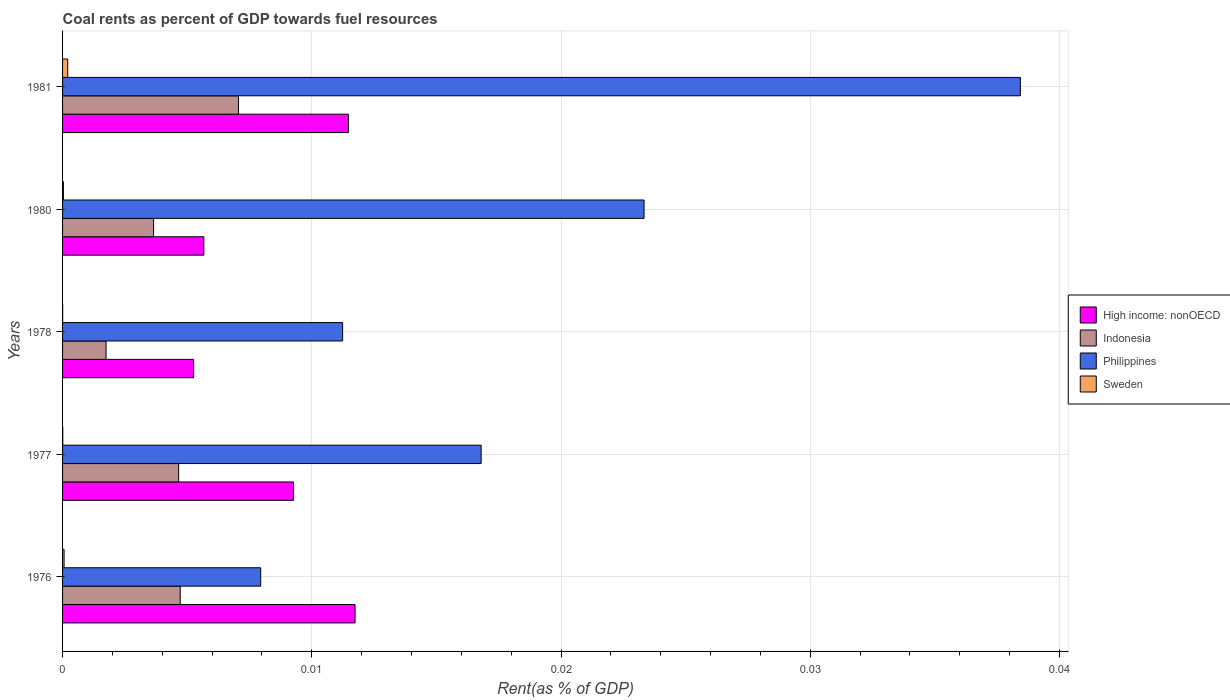How many bars are there on the 3rd tick from the bottom?
Give a very brief answer. 4. What is the coal rent in Indonesia in 1977?
Provide a succinct answer. 0. Across all years, what is the maximum coal rent in Sweden?
Make the answer very short. 0. Across all years, what is the minimum coal rent in High income: nonOECD?
Make the answer very short. 0.01. In which year was the coal rent in High income: nonOECD maximum?
Your answer should be very brief. 1976. In which year was the coal rent in Philippines minimum?
Your answer should be very brief. 1976. What is the total coal rent in High income: nonOECD in the graph?
Your answer should be very brief. 0.04. What is the difference between the coal rent in Indonesia in 1978 and that in 1980?
Provide a succinct answer. -0. What is the difference between the coal rent in High income: nonOECD in 1980 and the coal rent in Indonesia in 1977?
Your answer should be very brief. 0. What is the average coal rent in Indonesia per year?
Ensure brevity in your answer.  0. In the year 1981, what is the difference between the coal rent in High income: nonOECD and coal rent in Indonesia?
Keep it short and to the point. 0. What is the ratio of the coal rent in Indonesia in 1978 to that in 1981?
Offer a terse response. 0.25. What is the difference between the highest and the second highest coal rent in Philippines?
Offer a very short reply. 0.02. What is the difference between the highest and the lowest coal rent in Sweden?
Make the answer very short. 0. Is it the case that in every year, the sum of the coal rent in Sweden and coal rent in Philippines is greater than the sum of coal rent in Indonesia and coal rent in High income: nonOECD?
Ensure brevity in your answer.  No. What does the 2nd bar from the top in 1978 represents?
Give a very brief answer. Philippines. What does the 1st bar from the bottom in 1977 represents?
Give a very brief answer. High income: nonOECD. Is it the case that in every year, the sum of the coal rent in Sweden and coal rent in Indonesia is greater than the coal rent in High income: nonOECD?
Offer a very short reply. No. How many years are there in the graph?
Offer a terse response. 5. What is the difference between two consecutive major ticks on the X-axis?
Give a very brief answer. 0.01. Does the graph contain any zero values?
Provide a short and direct response. No. Does the graph contain grids?
Your response must be concise. Yes. How many legend labels are there?
Your answer should be very brief. 4. What is the title of the graph?
Your response must be concise. Coal rents as percent of GDP towards fuel resources. Does "Zambia" appear as one of the legend labels in the graph?
Your answer should be very brief. No. What is the label or title of the X-axis?
Give a very brief answer. Rent(as % of GDP). What is the label or title of the Y-axis?
Your answer should be compact. Years. What is the Rent(as % of GDP) in High income: nonOECD in 1976?
Provide a short and direct response. 0.01. What is the Rent(as % of GDP) in Indonesia in 1976?
Provide a succinct answer. 0. What is the Rent(as % of GDP) of Philippines in 1976?
Offer a terse response. 0.01. What is the Rent(as % of GDP) in Sweden in 1976?
Provide a succinct answer. 6.06616895971239e-5. What is the Rent(as % of GDP) in High income: nonOECD in 1977?
Offer a very short reply. 0.01. What is the Rent(as % of GDP) in Indonesia in 1977?
Offer a very short reply. 0. What is the Rent(as % of GDP) in Philippines in 1977?
Ensure brevity in your answer.  0.02. What is the Rent(as % of GDP) in Sweden in 1977?
Give a very brief answer. 8.869305403427698e-6. What is the Rent(as % of GDP) in High income: nonOECD in 1978?
Offer a very short reply. 0.01. What is the Rent(as % of GDP) in Indonesia in 1978?
Your response must be concise. 0. What is the Rent(as % of GDP) of Philippines in 1978?
Offer a very short reply. 0.01. What is the Rent(as % of GDP) in Sweden in 1978?
Offer a terse response. 4.018528953786889e-6. What is the Rent(as % of GDP) in High income: nonOECD in 1980?
Your answer should be compact. 0.01. What is the Rent(as % of GDP) of Indonesia in 1980?
Provide a succinct answer. 0. What is the Rent(as % of GDP) of Philippines in 1980?
Your answer should be compact. 0.02. What is the Rent(as % of GDP) in Sweden in 1980?
Keep it short and to the point. 3.34719228458372e-5. What is the Rent(as % of GDP) in High income: nonOECD in 1981?
Your response must be concise. 0.01. What is the Rent(as % of GDP) in Indonesia in 1981?
Your answer should be compact. 0.01. What is the Rent(as % of GDP) in Philippines in 1981?
Offer a terse response. 0.04. What is the Rent(as % of GDP) of Sweden in 1981?
Provide a short and direct response. 0. Across all years, what is the maximum Rent(as % of GDP) of High income: nonOECD?
Your answer should be compact. 0.01. Across all years, what is the maximum Rent(as % of GDP) in Indonesia?
Give a very brief answer. 0.01. Across all years, what is the maximum Rent(as % of GDP) in Philippines?
Keep it short and to the point. 0.04. Across all years, what is the maximum Rent(as % of GDP) in Sweden?
Offer a terse response. 0. Across all years, what is the minimum Rent(as % of GDP) in High income: nonOECD?
Give a very brief answer. 0.01. Across all years, what is the minimum Rent(as % of GDP) in Indonesia?
Give a very brief answer. 0. Across all years, what is the minimum Rent(as % of GDP) in Philippines?
Your answer should be compact. 0.01. Across all years, what is the minimum Rent(as % of GDP) in Sweden?
Ensure brevity in your answer.  4.018528953786889e-6. What is the total Rent(as % of GDP) of High income: nonOECD in the graph?
Provide a short and direct response. 0.04. What is the total Rent(as % of GDP) in Indonesia in the graph?
Your answer should be compact. 0.02. What is the total Rent(as % of GDP) in Philippines in the graph?
Ensure brevity in your answer.  0.1. What is the total Rent(as % of GDP) in Sweden in the graph?
Offer a very short reply. 0. What is the difference between the Rent(as % of GDP) in High income: nonOECD in 1976 and that in 1977?
Keep it short and to the point. 0. What is the difference between the Rent(as % of GDP) of Indonesia in 1976 and that in 1977?
Provide a short and direct response. 0. What is the difference between the Rent(as % of GDP) of Philippines in 1976 and that in 1977?
Keep it short and to the point. -0.01. What is the difference between the Rent(as % of GDP) in High income: nonOECD in 1976 and that in 1978?
Your answer should be very brief. 0.01. What is the difference between the Rent(as % of GDP) in Indonesia in 1976 and that in 1978?
Offer a terse response. 0. What is the difference between the Rent(as % of GDP) of Philippines in 1976 and that in 1978?
Ensure brevity in your answer.  -0. What is the difference between the Rent(as % of GDP) in High income: nonOECD in 1976 and that in 1980?
Provide a short and direct response. 0.01. What is the difference between the Rent(as % of GDP) of Indonesia in 1976 and that in 1980?
Make the answer very short. 0. What is the difference between the Rent(as % of GDP) in Philippines in 1976 and that in 1980?
Offer a terse response. -0.02. What is the difference between the Rent(as % of GDP) of Sweden in 1976 and that in 1980?
Offer a very short reply. 0. What is the difference between the Rent(as % of GDP) of High income: nonOECD in 1976 and that in 1981?
Make the answer very short. 0. What is the difference between the Rent(as % of GDP) in Indonesia in 1976 and that in 1981?
Keep it short and to the point. -0. What is the difference between the Rent(as % of GDP) in Philippines in 1976 and that in 1981?
Your answer should be very brief. -0.03. What is the difference between the Rent(as % of GDP) in Sweden in 1976 and that in 1981?
Offer a terse response. -0. What is the difference between the Rent(as % of GDP) of High income: nonOECD in 1977 and that in 1978?
Keep it short and to the point. 0. What is the difference between the Rent(as % of GDP) in Indonesia in 1977 and that in 1978?
Your answer should be compact. 0. What is the difference between the Rent(as % of GDP) of Philippines in 1977 and that in 1978?
Your answer should be compact. 0.01. What is the difference between the Rent(as % of GDP) in High income: nonOECD in 1977 and that in 1980?
Your answer should be compact. 0. What is the difference between the Rent(as % of GDP) of Indonesia in 1977 and that in 1980?
Your response must be concise. 0. What is the difference between the Rent(as % of GDP) in Philippines in 1977 and that in 1980?
Give a very brief answer. -0.01. What is the difference between the Rent(as % of GDP) in Sweden in 1977 and that in 1980?
Your response must be concise. -0. What is the difference between the Rent(as % of GDP) of High income: nonOECD in 1977 and that in 1981?
Your response must be concise. -0. What is the difference between the Rent(as % of GDP) in Indonesia in 1977 and that in 1981?
Your answer should be very brief. -0. What is the difference between the Rent(as % of GDP) in Philippines in 1977 and that in 1981?
Offer a very short reply. -0.02. What is the difference between the Rent(as % of GDP) of Sweden in 1977 and that in 1981?
Make the answer very short. -0. What is the difference between the Rent(as % of GDP) in High income: nonOECD in 1978 and that in 1980?
Make the answer very short. -0. What is the difference between the Rent(as % of GDP) of Indonesia in 1978 and that in 1980?
Provide a short and direct response. -0. What is the difference between the Rent(as % of GDP) in Philippines in 1978 and that in 1980?
Your response must be concise. -0.01. What is the difference between the Rent(as % of GDP) of High income: nonOECD in 1978 and that in 1981?
Your answer should be very brief. -0.01. What is the difference between the Rent(as % of GDP) of Indonesia in 1978 and that in 1981?
Your answer should be compact. -0.01. What is the difference between the Rent(as % of GDP) of Philippines in 1978 and that in 1981?
Your answer should be very brief. -0.03. What is the difference between the Rent(as % of GDP) in Sweden in 1978 and that in 1981?
Give a very brief answer. -0. What is the difference between the Rent(as % of GDP) of High income: nonOECD in 1980 and that in 1981?
Keep it short and to the point. -0.01. What is the difference between the Rent(as % of GDP) in Indonesia in 1980 and that in 1981?
Provide a succinct answer. -0. What is the difference between the Rent(as % of GDP) in Philippines in 1980 and that in 1981?
Give a very brief answer. -0.02. What is the difference between the Rent(as % of GDP) of Sweden in 1980 and that in 1981?
Ensure brevity in your answer.  -0. What is the difference between the Rent(as % of GDP) in High income: nonOECD in 1976 and the Rent(as % of GDP) in Indonesia in 1977?
Keep it short and to the point. 0.01. What is the difference between the Rent(as % of GDP) in High income: nonOECD in 1976 and the Rent(as % of GDP) in Philippines in 1977?
Your response must be concise. -0.01. What is the difference between the Rent(as % of GDP) of High income: nonOECD in 1976 and the Rent(as % of GDP) of Sweden in 1977?
Your response must be concise. 0.01. What is the difference between the Rent(as % of GDP) of Indonesia in 1976 and the Rent(as % of GDP) of Philippines in 1977?
Give a very brief answer. -0.01. What is the difference between the Rent(as % of GDP) in Indonesia in 1976 and the Rent(as % of GDP) in Sweden in 1977?
Your response must be concise. 0. What is the difference between the Rent(as % of GDP) in Philippines in 1976 and the Rent(as % of GDP) in Sweden in 1977?
Your response must be concise. 0.01. What is the difference between the Rent(as % of GDP) in High income: nonOECD in 1976 and the Rent(as % of GDP) in Philippines in 1978?
Give a very brief answer. 0. What is the difference between the Rent(as % of GDP) in High income: nonOECD in 1976 and the Rent(as % of GDP) in Sweden in 1978?
Your answer should be compact. 0.01. What is the difference between the Rent(as % of GDP) of Indonesia in 1976 and the Rent(as % of GDP) of Philippines in 1978?
Your answer should be very brief. -0.01. What is the difference between the Rent(as % of GDP) of Indonesia in 1976 and the Rent(as % of GDP) of Sweden in 1978?
Your answer should be very brief. 0. What is the difference between the Rent(as % of GDP) of Philippines in 1976 and the Rent(as % of GDP) of Sweden in 1978?
Keep it short and to the point. 0.01. What is the difference between the Rent(as % of GDP) in High income: nonOECD in 1976 and the Rent(as % of GDP) in Indonesia in 1980?
Your answer should be very brief. 0.01. What is the difference between the Rent(as % of GDP) of High income: nonOECD in 1976 and the Rent(as % of GDP) of Philippines in 1980?
Provide a short and direct response. -0.01. What is the difference between the Rent(as % of GDP) of High income: nonOECD in 1976 and the Rent(as % of GDP) of Sweden in 1980?
Provide a short and direct response. 0.01. What is the difference between the Rent(as % of GDP) of Indonesia in 1976 and the Rent(as % of GDP) of Philippines in 1980?
Provide a short and direct response. -0.02. What is the difference between the Rent(as % of GDP) in Indonesia in 1976 and the Rent(as % of GDP) in Sweden in 1980?
Offer a very short reply. 0. What is the difference between the Rent(as % of GDP) in Philippines in 1976 and the Rent(as % of GDP) in Sweden in 1980?
Provide a short and direct response. 0.01. What is the difference between the Rent(as % of GDP) of High income: nonOECD in 1976 and the Rent(as % of GDP) of Indonesia in 1981?
Make the answer very short. 0. What is the difference between the Rent(as % of GDP) in High income: nonOECD in 1976 and the Rent(as % of GDP) in Philippines in 1981?
Your response must be concise. -0.03. What is the difference between the Rent(as % of GDP) of High income: nonOECD in 1976 and the Rent(as % of GDP) of Sweden in 1981?
Give a very brief answer. 0.01. What is the difference between the Rent(as % of GDP) of Indonesia in 1976 and the Rent(as % of GDP) of Philippines in 1981?
Give a very brief answer. -0.03. What is the difference between the Rent(as % of GDP) of Indonesia in 1976 and the Rent(as % of GDP) of Sweden in 1981?
Ensure brevity in your answer.  0. What is the difference between the Rent(as % of GDP) in Philippines in 1976 and the Rent(as % of GDP) in Sweden in 1981?
Your answer should be compact. 0.01. What is the difference between the Rent(as % of GDP) of High income: nonOECD in 1977 and the Rent(as % of GDP) of Indonesia in 1978?
Provide a short and direct response. 0.01. What is the difference between the Rent(as % of GDP) of High income: nonOECD in 1977 and the Rent(as % of GDP) of Philippines in 1978?
Make the answer very short. -0. What is the difference between the Rent(as % of GDP) of High income: nonOECD in 1977 and the Rent(as % of GDP) of Sweden in 1978?
Provide a short and direct response. 0.01. What is the difference between the Rent(as % of GDP) in Indonesia in 1977 and the Rent(as % of GDP) in Philippines in 1978?
Make the answer very short. -0.01. What is the difference between the Rent(as % of GDP) in Indonesia in 1977 and the Rent(as % of GDP) in Sweden in 1978?
Provide a succinct answer. 0. What is the difference between the Rent(as % of GDP) in Philippines in 1977 and the Rent(as % of GDP) in Sweden in 1978?
Your answer should be very brief. 0.02. What is the difference between the Rent(as % of GDP) in High income: nonOECD in 1977 and the Rent(as % of GDP) in Indonesia in 1980?
Provide a succinct answer. 0.01. What is the difference between the Rent(as % of GDP) of High income: nonOECD in 1977 and the Rent(as % of GDP) of Philippines in 1980?
Provide a short and direct response. -0.01. What is the difference between the Rent(as % of GDP) of High income: nonOECD in 1977 and the Rent(as % of GDP) of Sweden in 1980?
Offer a terse response. 0.01. What is the difference between the Rent(as % of GDP) in Indonesia in 1977 and the Rent(as % of GDP) in Philippines in 1980?
Offer a very short reply. -0.02. What is the difference between the Rent(as % of GDP) of Indonesia in 1977 and the Rent(as % of GDP) of Sweden in 1980?
Keep it short and to the point. 0. What is the difference between the Rent(as % of GDP) of Philippines in 1977 and the Rent(as % of GDP) of Sweden in 1980?
Ensure brevity in your answer.  0.02. What is the difference between the Rent(as % of GDP) of High income: nonOECD in 1977 and the Rent(as % of GDP) of Indonesia in 1981?
Your answer should be very brief. 0. What is the difference between the Rent(as % of GDP) in High income: nonOECD in 1977 and the Rent(as % of GDP) in Philippines in 1981?
Your response must be concise. -0.03. What is the difference between the Rent(as % of GDP) of High income: nonOECD in 1977 and the Rent(as % of GDP) of Sweden in 1981?
Your answer should be very brief. 0.01. What is the difference between the Rent(as % of GDP) of Indonesia in 1977 and the Rent(as % of GDP) of Philippines in 1981?
Offer a very short reply. -0.03. What is the difference between the Rent(as % of GDP) in Indonesia in 1977 and the Rent(as % of GDP) in Sweden in 1981?
Provide a succinct answer. 0. What is the difference between the Rent(as % of GDP) in Philippines in 1977 and the Rent(as % of GDP) in Sweden in 1981?
Provide a succinct answer. 0.02. What is the difference between the Rent(as % of GDP) of High income: nonOECD in 1978 and the Rent(as % of GDP) of Indonesia in 1980?
Provide a short and direct response. 0. What is the difference between the Rent(as % of GDP) of High income: nonOECD in 1978 and the Rent(as % of GDP) of Philippines in 1980?
Your response must be concise. -0.02. What is the difference between the Rent(as % of GDP) of High income: nonOECD in 1978 and the Rent(as % of GDP) of Sweden in 1980?
Ensure brevity in your answer.  0.01. What is the difference between the Rent(as % of GDP) in Indonesia in 1978 and the Rent(as % of GDP) in Philippines in 1980?
Keep it short and to the point. -0.02. What is the difference between the Rent(as % of GDP) of Indonesia in 1978 and the Rent(as % of GDP) of Sweden in 1980?
Ensure brevity in your answer.  0. What is the difference between the Rent(as % of GDP) of Philippines in 1978 and the Rent(as % of GDP) of Sweden in 1980?
Your answer should be compact. 0.01. What is the difference between the Rent(as % of GDP) in High income: nonOECD in 1978 and the Rent(as % of GDP) in Indonesia in 1981?
Your response must be concise. -0. What is the difference between the Rent(as % of GDP) in High income: nonOECD in 1978 and the Rent(as % of GDP) in Philippines in 1981?
Make the answer very short. -0.03. What is the difference between the Rent(as % of GDP) in High income: nonOECD in 1978 and the Rent(as % of GDP) in Sweden in 1981?
Make the answer very short. 0.01. What is the difference between the Rent(as % of GDP) of Indonesia in 1978 and the Rent(as % of GDP) of Philippines in 1981?
Offer a terse response. -0.04. What is the difference between the Rent(as % of GDP) of Indonesia in 1978 and the Rent(as % of GDP) of Sweden in 1981?
Provide a short and direct response. 0. What is the difference between the Rent(as % of GDP) of Philippines in 1978 and the Rent(as % of GDP) of Sweden in 1981?
Offer a terse response. 0.01. What is the difference between the Rent(as % of GDP) of High income: nonOECD in 1980 and the Rent(as % of GDP) of Indonesia in 1981?
Your answer should be very brief. -0. What is the difference between the Rent(as % of GDP) in High income: nonOECD in 1980 and the Rent(as % of GDP) in Philippines in 1981?
Make the answer very short. -0.03. What is the difference between the Rent(as % of GDP) of High income: nonOECD in 1980 and the Rent(as % of GDP) of Sweden in 1981?
Ensure brevity in your answer.  0.01. What is the difference between the Rent(as % of GDP) of Indonesia in 1980 and the Rent(as % of GDP) of Philippines in 1981?
Offer a very short reply. -0.03. What is the difference between the Rent(as % of GDP) in Indonesia in 1980 and the Rent(as % of GDP) in Sweden in 1981?
Give a very brief answer. 0. What is the difference between the Rent(as % of GDP) in Philippines in 1980 and the Rent(as % of GDP) in Sweden in 1981?
Your response must be concise. 0.02. What is the average Rent(as % of GDP) of High income: nonOECD per year?
Give a very brief answer. 0.01. What is the average Rent(as % of GDP) of Indonesia per year?
Provide a short and direct response. 0. What is the average Rent(as % of GDP) of Philippines per year?
Give a very brief answer. 0.02. What is the average Rent(as % of GDP) in Sweden per year?
Ensure brevity in your answer.  0. In the year 1976, what is the difference between the Rent(as % of GDP) in High income: nonOECD and Rent(as % of GDP) in Indonesia?
Give a very brief answer. 0.01. In the year 1976, what is the difference between the Rent(as % of GDP) of High income: nonOECD and Rent(as % of GDP) of Philippines?
Make the answer very short. 0. In the year 1976, what is the difference between the Rent(as % of GDP) of High income: nonOECD and Rent(as % of GDP) of Sweden?
Provide a succinct answer. 0.01. In the year 1976, what is the difference between the Rent(as % of GDP) of Indonesia and Rent(as % of GDP) of Philippines?
Your response must be concise. -0. In the year 1976, what is the difference between the Rent(as % of GDP) in Indonesia and Rent(as % of GDP) in Sweden?
Offer a very short reply. 0. In the year 1976, what is the difference between the Rent(as % of GDP) of Philippines and Rent(as % of GDP) of Sweden?
Ensure brevity in your answer.  0.01. In the year 1977, what is the difference between the Rent(as % of GDP) of High income: nonOECD and Rent(as % of GDP) of Indonesia?
Offer a terse response. 0. In the year 1977, what is the difference between the Rent(as % of GDP) of High income: nonOECD and Rent(as % of GDP) of Philippines?
Offer a very short reply. -0.01. In the year 1977, what is the difference between the Rent(as % of GDP) of High income: nonOECD and Rent(as % of GDP) of Sweden?
Offer a terse response. 0.01. In the year 1977, what is the difference between the Rent(as % of GDP) of Indonesia and Rent(as % of GDP) of Philippines?
Keep it short and to the point. -0.01. In the year 1977, what is the difference between the Rent(as % of GDP) in Indonesia and Rent(as % of GDP) in Sweden?
Your answer should be compact. 0. In the year 1977, what is the difference between the Rent(as % of GDP) in Philippines and Rent(as % of GDP) in Sweden?
Offer a terse response. 0.02. In the year 1978, what is the difference between the Rent(as % of GDP) in High income: nonOECD and Rent(as % of GDP) in Indonesia?
Provide a succinct answer. 0. In the year 1978, what is the difference between the Rent(as % of GDP) in High income: nonOECD and Rent(as % of GDP) in Philippines?
Your response must be concise. -0.01. In the year 1978, what is the difference between the Rent(as % of GDP) in High income: nonOECD and Rent(as % of GDP) in Sweden?
Your answer should be compact. 0.01. In the year 1978, what is the difference between the Rent(as % of GDP) in Indonesia and Rent(as % of GDP) in Philippines?
Your answer should be compact. -0.01. In the year 1978, what is the difference between the Rent(as % of GDP) in Indonesia and Rent(as % of GDP) in Sweden?
Provide a short and direct response. 0. In the year 1978, what is the difference between the Rent(as % of GDP) in Philippines and Rent(as % of GDP) in Sweden?
Provide a succinct answer. 0.01. In the year 1980, what is the difference between the Rent(as % of GDP) in High income: nonOECD and Rent(as % of GDP) in Indonesia?
Give a very brief answer. 0. In the year 1980, what is the difference between the Rent(as % of GDP) in High income: nonOECD and Rent(as % of GDP) in Philippines?
Your response must be concise. -0.02. In the year 1980, what is the difference between the Rent(as % of GDP) of High income: nonOECD and Rent(as % of GDP) of Sweden?
Make the answer very short. 0.01. In the year 1980, what is the difference between the Rent(as % of GDP) of Indonesia and Rent(as % of GDP) of Philippines?
Your response must be concise. -0.02. In the year 1980, what is the difference between the Rent(as % of GDP) in Indonesia and Rent(as % of GDP) in Sweden?
Ensure brevity in your answer.  0. In the year 1980, what is the difference between the Rent(as % of GDP) in Philippines and Rent(as % of GDP) in Sweden?
Offer a terse response. 0.02. In the year 1981, what is the difference between the Rent(as % of GDP) in High income: nonOECD and Rent(as % of GDP) in Indonesia?
Provide a succinct answer. 0. In the year 1981, what is the difference between the Rent(as % of GDP) in High income: nonOECD and Rent(as % of GDP) in Philippines?
Keep it short and to the point. -0.03. In the year 1981, what is the difference between the Rent(as % of GDP) in High income: nonOECD and Rent(as % of GDP) in Sweden?
Make the answer very short. 0.01. In the year 1981, what is the difference between the Rent(as % of GDP) of Indonesia and Rent(as % of GDP) of Philippines?
Your answer should be compact. -0.03. In the year 1981, what is the difference between the Rent(as % of GDP) in Indonesia and Rent(as % of GDP) in Sweden?
Provide a short and direct response. 0.01. In the year 1981, what is the difference between the Rent(as % of GDP) of Philippines and Rent(as % of GDP) of Sweden?
Keep it short and to the point. 0.04. What is the ratio of the Rent(as % of GDP) of High income: nonOECD in 1976 to that in 1977?
Keep it short and to the point. 1.27. What is the ratio of the Rent(as % of GDP) of Indonesia in 1976 to that in 1977?
Keep it short and to the point. 1.01. What is the ratio of the Rent(as % of GDP) in Philippines in 1976 to that in 1977?
Your answer should be compact. 0.47. What is the ratio of the Rent(as % of GDP) of Sweden in 1976 to that in 1977?
Your answer should be very brief. 6.84. What is the ratio of the Rent(as % of GDP) of High income: nonOECD in 1976 to that in 1978?
Provide a succinct answer. 2.23. What is the ratio of the Rent(as % of GDP) in Indonesia in 1976 to that in 1978?
Offer a very short reply. 2.71. What is the ratio of the Rent(as % of GDP) in Philippines in 1976 to that in 1978?
Your response must be concise. 0.71. What is the ratio of the Rent(as % of GDP) in Sweden in 1976 to that in 1978?
Your answer should be compact. 15.1. What is the ratio of the Rent(as % of GDP) of High income: nonOECD in 1976 to that in 1980?
Offer a terse response. 2.07. What is the ratio of the Rent(as % of GDP) in Indonesia in 1976 to that in 1980?
Ensure brevity in your answer.  1.29. What is the ratio of the Rent(as % of GDP) of Philippines in 1976 to that in 1980?
Your answer should be very brief. 0.34. What is the ratio of the Rent(as % of GDP) of Sweden in 1976 to that in 1980?
Your response must be concise. 1.81. What is the ratio of the Rent(as % of GDP) of High income: nonOECD in 1976 to that in 1981?
Offer a terse response. 1.02. What is the ratio of the Rent(as % of GDP) in Indonesia in 1976 to that in 1981?
Make the answer very short. 0.67. What is the ratio of the Rent(as % of GDP) in Philippines in 1976 to that in 1981?
Make the answer very short. 0.21. What is the ratio of the Rent(as % of GDP) in Sweden in 1976 to that in 1981?
Your response must be concise. 0.29. What is the ratio of the Rent(as % of GDP) of High income: nonOECD in 1977 to that in 1978?
Ensure brevity in your answer.  1.76. What is the ratio of the Rent(as % of GDP) of Indonesia in 1977 to that in 1978?
Provide a short and direct response. 2.67. What is the ratio of the Rent(as % of GDP) in Philippines in 1977 to that in 1978?
Provide a short and direct response. 1.49. What is the ratio of the Rent(as % of GDP) of Sweden in 1977 to that in 1978?
Your response must be concise. 2.21. What is the ratio of the Rent(as % of GDP) in High income: nonOECD in 1977 to that in 1980?
Offer a terse response. 1.63. What is the ratio of the Rent(as % of GDP) in Indonesia in 1977 to that in 1980?
Offer a terse response. 1.28. What is the ratio of the Rent(as % of GDP) of Philippines in 1977 to that in 1980?
Ensure brevity in your answer.  0.72. What is the ratio of the Rent(as % of GDP) in Sweden in 1977 to that in 1980?
Make the answer very short. 0.27. What is the ratio of the Rent(as % of GDP) of High income: nonOECD in 1977 to that in 1981?
Keep it short and to the point. 0.81. What is the ratio of the Rent(as % of GDP) of Indonesia in 1977 to that in 1981?
Your answer should be compact. 0.66. What is the ratio of the Rent(as % of GDP) in Philippines in 1977 to that in 1981?
Your answer should be very brief. 0.44. What is the ratio of the Rent(as % of GDP) in Sweden in 1977 to that in 1981?
Provide a short and direct response. 0.04. What is the ratio of the Rent(as % of GDP) of High income: nonOECD in 1978 to that in 1980?
Your answer should be compact. 0.93. What is the ratio of the Rent(as % of GDP) of Indonesia in 1978 to that in 1980?
Your response must be concise. 0.48. What is the ratio of the Rent(as % of GDP) of Philippines in 1978 to that in 1980?
Offer a terse response. 0.48. What is the ratio of the Rent(as % of GDP) of Sweden in 1978 to that in 1980?
Your answer should be very brief. 0.12. What is the ratio of the Rent(as % of GDP) in High income: nonOECD in 1978 to that in 1981?
Provide a short and direct response. 0.46. What is the ratio of the Rent(as % of GDP) of Indonesia in 1978 to that in 1981?
Offer a terse response. 0.25. What is the ratio of the Rent(as % of GDP) of Philippines in 1978 to that in 1981?
Your response must be concise. 0.29. What is the ratio of the Rent(as % of GDP) of Sweden in 1978 to that in 1981?
Ensure brevity in your answer.  0.02. What is the ratio of the Rent(as % of GDP) in High income: nonOECD in 1980 to that in 1981?
Your answer should be compact. 0.49. What is the ratio of the Rent(as % of GDP) in Indonesia in 1980 to that in 1981?
Keep it short and to the point. 0.52. What is the ratio of the Rent(as % of GDP) in Philippines in 1980 to that in 1981?
Offer a very short reply. 0.61. What is the ratio of the Rent(as % of GDP) of Sweden in 1980 to that in 1981?
Ensure brevity in your answer.  0.16. What is the difference between the highest and the second highest Rent(as % of GDP) in High income: nonOECD?
Provide a short and direct response. 0. What is the difference between the highest and the second highest Rent(as % of GDP) in Indonesia?
Ensure brevity in your answer.  0. What is the difference between the highest and the second highest Rent(as % of GDP) of Philippines?
Keep it short and to the point. 0.02. What is the difference between the highest and the lowest Rent(as % of GDP) in High income: nonOECD?
Keep it short and to the point. 0.01. What is the difference between the highest and the lowest Rent(as % of GDP) of Indonesia?
Offer a terse response. 0.01. What is the difference between the highest and the lowest Rent(as % of GDP) of Philippines?
Offer a very short reply. 0.03. What is the difference between the highest and the lowest Rent(as % of GDP) in Sweden?
Your answer should be very brief. 0. 